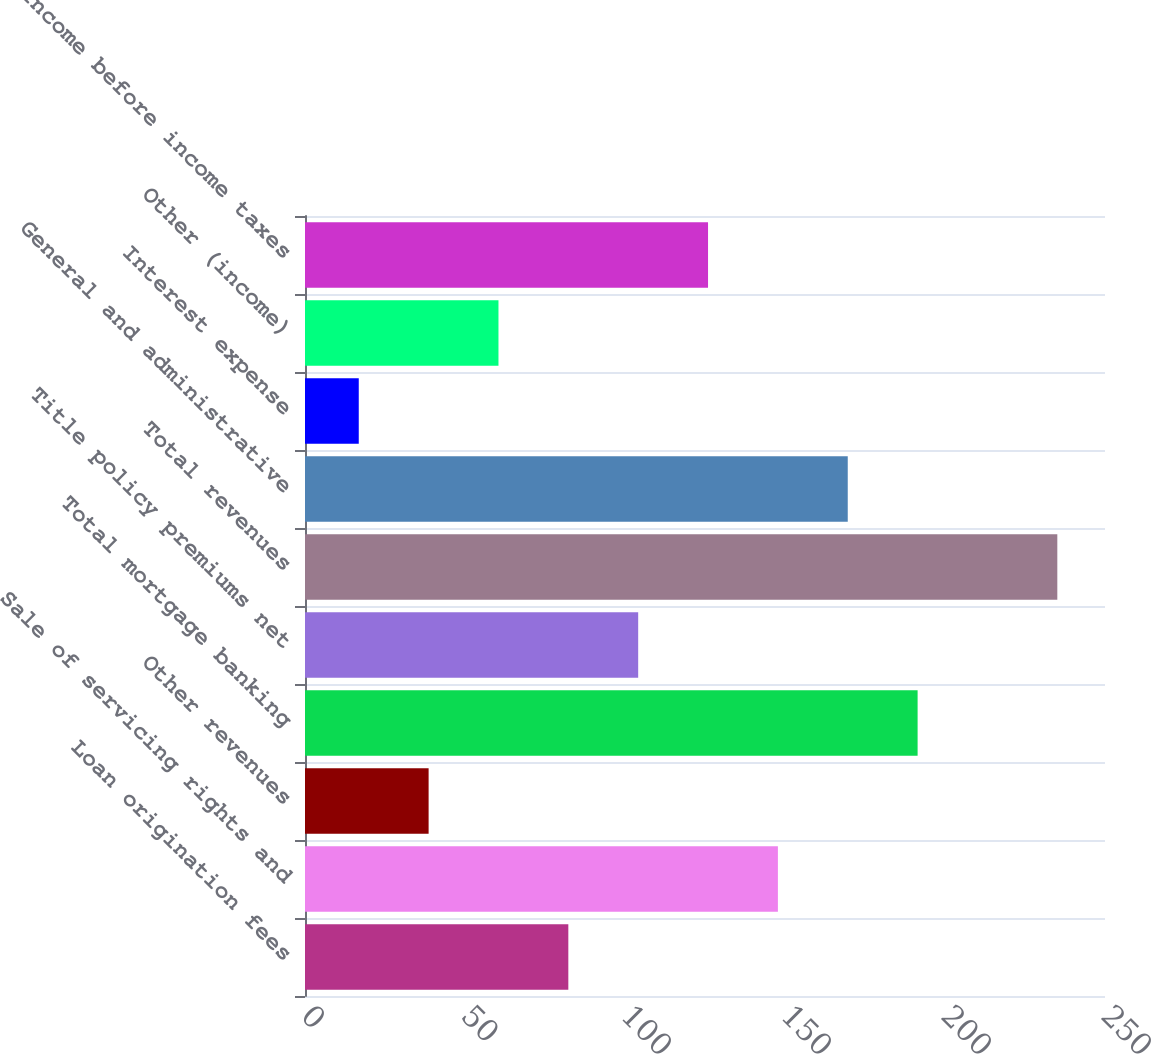Convert chart to OTSL. <chart><loc_0><loc_0><loc_500><loc_500><bar_chart><fcel>Loan origination fees<fcel>Sale of servicing rights and<fcel>Other revenues<fcel>Total mortgage banking<fcel>Title policy premiums net<fcel>Total revenues<fcel>General and administrative<fcel>Interest expense<fcel>Other (income)<fcel>Income before income taxes<nl><fcel>82.29<fcel>147.78<fcel>38.63<fcel>191.44<fcel>104.12<fcel>235.1<fcel>169.61<fcel>16.8<fcel>60.46<fcel>125.95<nl></chart> 